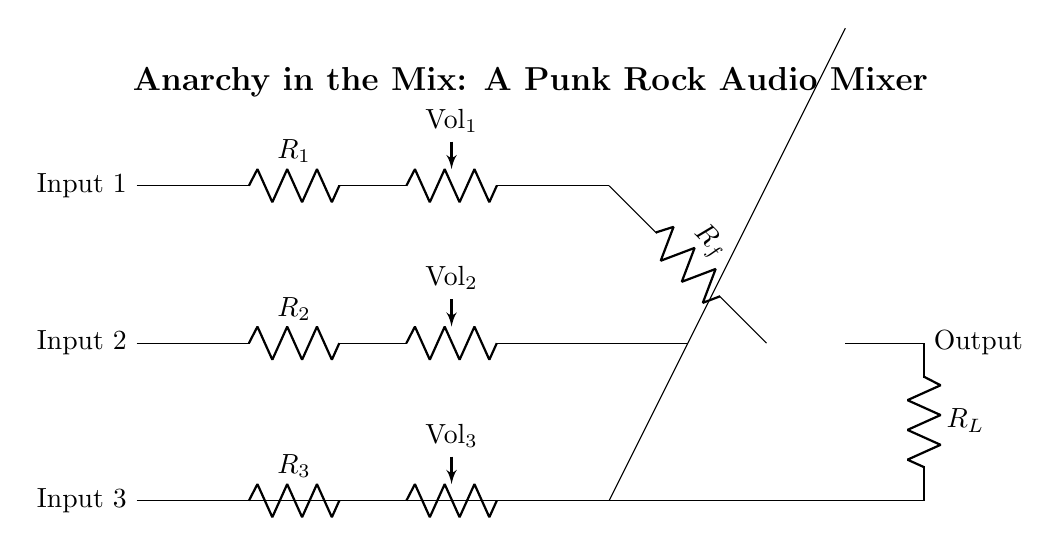What are the input components in this circuit? The circuit diagram clearly shows three input components, which are connected in parallel and labeled as Input 1, Input 2, and Input 3. These inputs each have a corresponding resistor and potentiometer (volume control).
Answer: Resistors and potentiometers How many channels of audio does this mixer handle? The circuit diagram indicates three separate paths for audio signals, represented by Input 1, Input 2, and Input 3, meaning it can handle three channels.
Answer: Three channels What is the role of the operational amplifier in this circuit? The operational amplifier takes the combined input signals from the three channels and amplifies them, providing the final mixed output. It's directly connected to the resistors from the input channels and processes the incoming signals.
Answer: Amplification What is the value of the feedback resistor labeled R_f? The diagram depicts a resistor labeled as R_f, which is used to set the gain of the operational amplifier but does not specify a numerical value; it is a symbolic representation in the diagram. Therefore, its exact resistance is not provided in this context.
Answer: Not specified What happens to the output signal of this mixer? The output signal is taken from the output of the operational amplifier and is directed through a load resistor, R_L, ultimately representing the mixed audio signal that can be sent to an output device such as speakers.
Answer: Sent to output device What does Vol represent in this circuit? The Vol label indicates that these are volume control potentiometers for each input channel, allowing the user to adjust the loudness of the signal coming from each channel individually.
Answer: Volume controls Which component is responsible for controlling the mix of input levels? The potentiometers labeled as Vol_1, Vol_2, and Vol_3 are responsible for controlling the mix of input levels, allowing the user to adjust the volume of each input before it is summed by the operational amplifier.
Answer: Potentiometers 